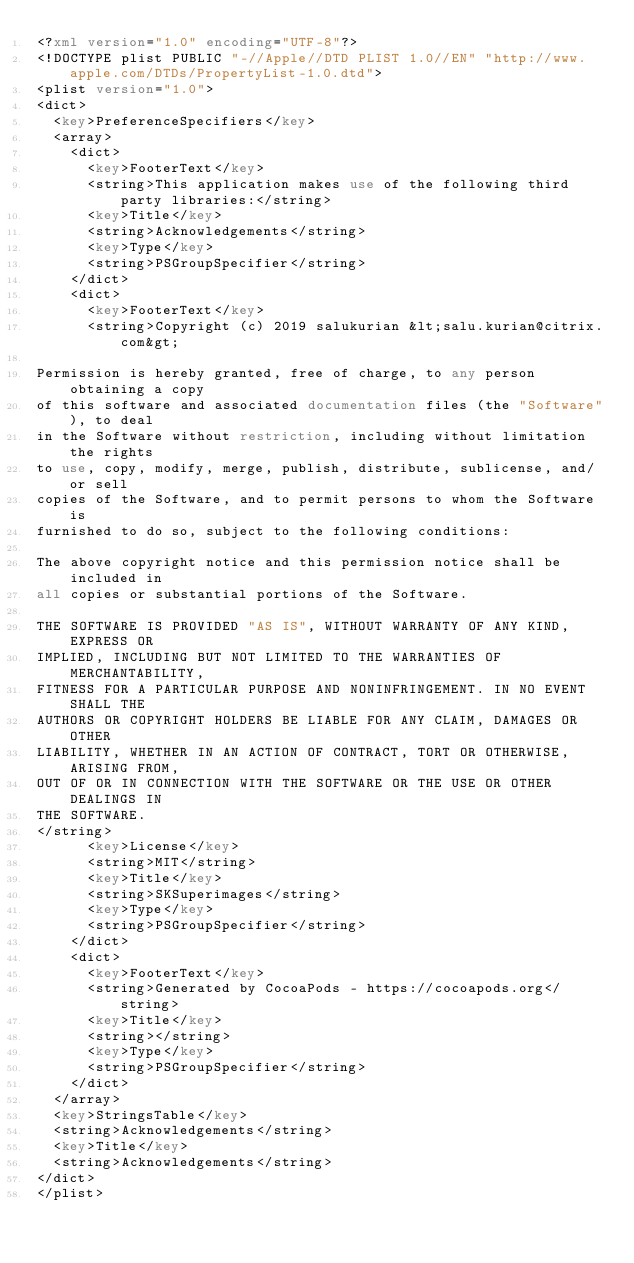<code> <loc_0><loc_0><loc_500><loc_500><_XML_><?xml version="1.0" encoding="UTF-8"?>
<!DOCTYPE plist PUBLIC "-//Apple//DTD PLIST 1.0//EN" "http://www.apple.com/DTDs/PropertyList-1.0.dtd">
<plist version="1.0">
<dict>
	<key>PreferenceSpecifiers</key>
	<array>
		<dict>
			<key>FooterText</key>
			<string>This application makes use of the following third party libraries:</string>
			<key>Title</key>
			<string>Acknowledgements</string>
			<key>Type</key>
			<string>PSGroupSpecifier</string>
		</dict>
		<dict>
			<key>FooterText</key>
			<string>Copyright (c) 2019 salukurian &lt;salu.kurian@citrix.com&gt;

Permission is hereby granted, free of charge, to any person obtaining a copy
of this software and associated documentation files (the "Software"), to deal
in the Software without restriction, including without limitation the rights
to use, copy, modify, merge, publish, distribute, sublicense, and/or sell
copies of the Software, and to permit persons to whom the Software is
furnished to do so, subject to the following conditions:

The above copyright notice and this permission notice shall be included in
all copies or substantial portions of the Software.

THE SOFTWARE IS PROVIDED "AS IS", WITHOUT WARRANTY OF ANY KIND, EXPRESS OR
IMPLIED, INCLUDING BUT NOT LIMITED TO THE WARRANTIES OF MERCHANTABILITY,
FITNESS FOR A PARTICULAR PURPOSE AND NONINFRINGEMENT. IN NO EVENT SHALL THE
AUTHORS OR COPYRIGHT HOLDERS BE LIABLE FOR ANY CLAIM, DAMAGES OR OTHER
LIABILITY, WHETHER IN AN ACTION OF CONTRACT, TORT OR OTHERWISE, ARISING FROM,
OUT OF OR IN CONNECTION WITH THE SOFTWARE OR THE USE OR OTHER DEALINGS IN
THE SOFTWARE.
</string>
			<key>License</key>
			<string>MIT</string>
			<key>Title</key>
			<string>SKSuperimages</string>
			<key>Type</key>
			<string>PSGroupSpecifier</string>
		</dict>
		<dict>
			<key>FooterText</key>
			<string>Generated by CocoaPods - https://cocoapods.org</string>
			<key>Title</key>
			<string></string>
			<key>Type</key>
			<string>PSGroupSpecifier</string>
		</dict>
	</array>
	<key>StringsTable</key>
	<string>Acknowledgements</string>
	<key>Title</key>
	<string>Acknowledgements</string>
</dict>
</plist>
</code> 